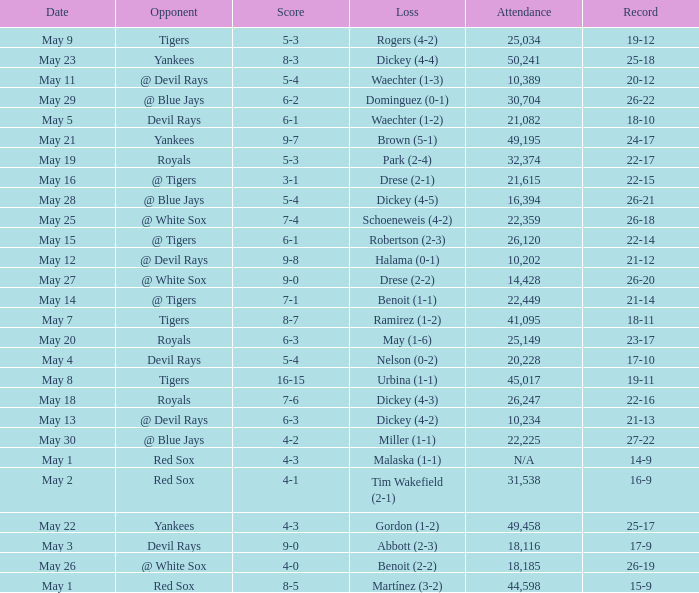What is the score of the game attended by 25,034? 5-3. 